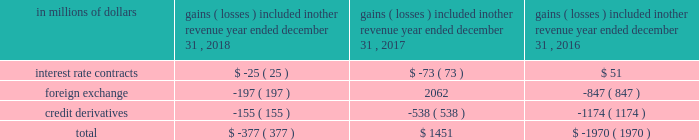For the years ended december a031 , 2018 , 2017 and 2016 , the amounts recognized in principal transactions in the consolidated statement of income related to derivatives not designated in a qualifying hedging relationship , as well as the underlying non-derivative instruments , are presented in note a06 to the consolidated financial statements .
Citigroup presents this disclosure by showing derivative gains and losses related to its trading activities together with gains and losses related to non-derivative instruments within the same trading portfolios , as this represents how these portfolios are risk managed .
The amounts recognized in other revenue in the consolidated statement of income related to derivatives not designated in a qualifying hedging relationship are shown below .
The table below does not include any offsetting gains ( losses ) on the economically hedged items to the extent that such amounts are also recorded in other revenue .
Gains ( losses ) included in other revenue year ended december 31 .
Accounting for derivative hedging citigroup accounts for its hedging activities in accordance with asc 815 , derivatives and hedging .
As a general rule , hedge accounting is permitted where the company is exposed to a particular risk , such as interest rate or foreign exchange risk , that causes changes in the fair value of an asset or liability or variability in the expected future cash flows of an existing asset , liability or a forecasted transaction that may affect earnings .
Derivative contracts hedging the risks associated with changes in fair value are referred to as fair value hedges , while contracts hedging the variability of expected future cash flows are cash flow hedges .
Hedges that utilize derivatives or debt instruments to manage the foreign exchange risk associated with equity investments in non-u.s.-dollar-functional- currency foreign subsidiaries ( net investment in a foreign operation ) are net investment hedges .
To qualify as an accounting hedge under the hedge accounting rules ( versus an economic hedge where hedge accounting is not applied ) , a hedging relationship must be highly effective in offsetting the risk designated as being hedged .
The hedging relationship must be formally documented at inception , detailing the particular risk management objective and strategy for the hedge .
This includes the item and risk ( s ) being hedged , the hedging instrument being used and how effectiveness will be assessed .
The effectiveness of these hedging relationships is evaluated at hedge inception and on an ongoing basis both on a retrospective and prospective basis , typically using quantitative measures of correlation , with hedge ineffectiveness measured and recorded in current earnings .
Hedge effectiveness assessment methodologies are performed in a similar manner for similar hedges , and are used consistently throughout the hedging relationships .
The assessment of effectiveness may exclude changes in the value of the hedged item that are unrelated to the risks being hedged and the changes in fair value of the derivative associated with time value .
Prior to january 1 , 2018 , these excluded items were recognized in current earnings for the hedging derivative , while changes in the value of a hedged item that were not related to the hedged risk were not recorded .
Upon adoption of asc 2017-12 , citi excludes changes in the cross currency basis associated with cross currency swaps from the assessment of hedge effectiveness and records it in other comprehensive income .
Discontinued hedge accounting a hedging instrument must be highly effective in accomplishing the hedge objective of offsetting either changes in the fair value or cash flows of the hedged item for the risk being hedged .
Management may voluntarily de-designate an accounting hedge at any time , but if a hedging relationship is not highly effective , it no longer qualifies for hedge accounting and must be de-designated .
Subsequent changes in the fair value of the derivative are recognized in other revenue or principal transactions , similar to trading derivatives , with no offset recorded related to the hedged item .
For fair value hedges , any changes in the fair value of the hedged item remain as part of the basis of the asset or liability and are ultimately realized as an element of the yield on the item .
For cash flow hedges , changes in fair value of the end-user derivative remain in accumulated other comprehensive income ( loss ) ( aoci ) and are included in the earnings of future periods when the forecasted hedged cash flows impact earnings .
However , if it becomes probable that some or all of the hedged forecasted transactions will not occur , any amounts that remain in aoci related to these transactions must be immediately reflected in other revenue .
The foregoing criteria are applied on a decentralized basis , consistent with the level at which market risk is managed , but are subject to various limits and controls .
The underlying asset , liability or forecasted transaction may be an individual item or a portfolio of similar items. .
What was the change in millions in total gains ( losses ) included in other revenue between the year ended december 31 , 2016 and 2017? 
Computations: (1451 - -1970)
Answer: 3421.0. 